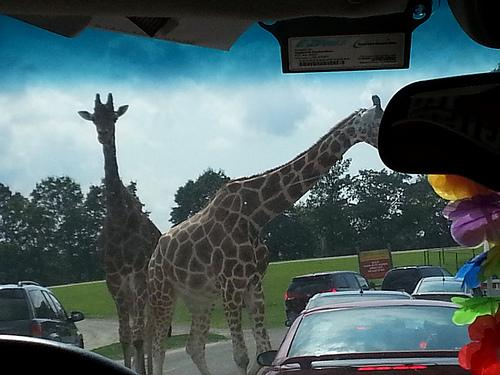Briefly explain the principal event occurring in the image. Giraffes interacting with people in cars on the road, with one giraffe peering into a vehicle. In a sentence, describe the main action taking place in the image. Giraffes on the road attract attention, with one giraffe approaching a car to inspect the passengers inside. Describe the primary scene occurring in the image. An interesting interaction between giraffes and people in vehicles, with one giraffe bending its head towards a car. Mention the primary object and its interaction in the image. A curious giraffe leans over a car, captivated by the passengers who document the extraordinary encounter. Explain the main scenario presented in the image. A couple of giraffes on a road surrounded by cars, with one giraffe approaching a car and looking inside. Illustrate the overall visual experience of the image. An exciting encounter with giraffes on a road, one bending towards a car while others drive by under a cloudy sky. Give a short account of the principal subject in the image and their activity. Two giraffes on a road, one of them leaning into a car, surrounded by other vehicles and a cloudy sky. Characterize the most prominent feature in the image and what's happening. A curious giraffe on a road leaning down to inspect the occupants of a nearby car with other vehicles around. Provide a brief description of the main focus in the image. Two giraffes stand near a road, with one leaning its head over a car as people inside capture the moment. Write a compact description of the central scene in the image. Encounter with two giraffes on the road, one looking inside a nearby car, set against a cloudy sky. 